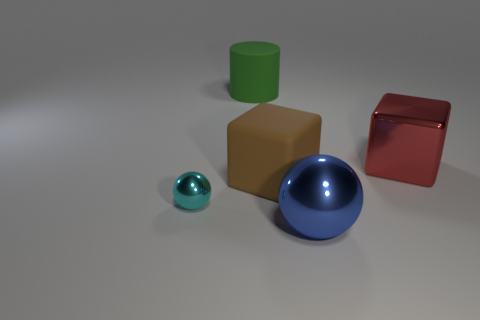Add 4 cyan metallic spheres. How many objects exist? 9 Subtract all cubes. How many objects are left? 3 Subtract all big brown cubes. Subtract all brown blocks. How many objects are left? 3 Add 3 big rubber things. How many big rubber things are left? 5 Add 1 metallic spheres. How many metallic spheres exist? 3 Subtract 0 blue blocks. How many objects are left? 5 